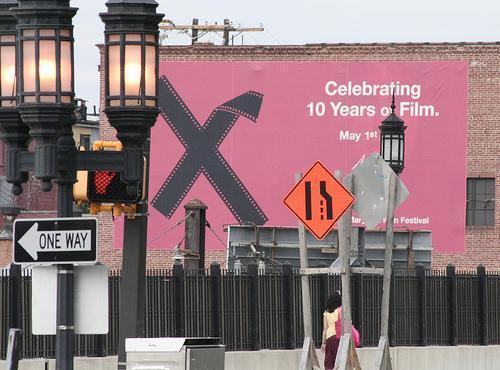How many street lights are there?
Give a very brief answer. 4. How many years are being celebrated?
Give a very brief answer. 10. 